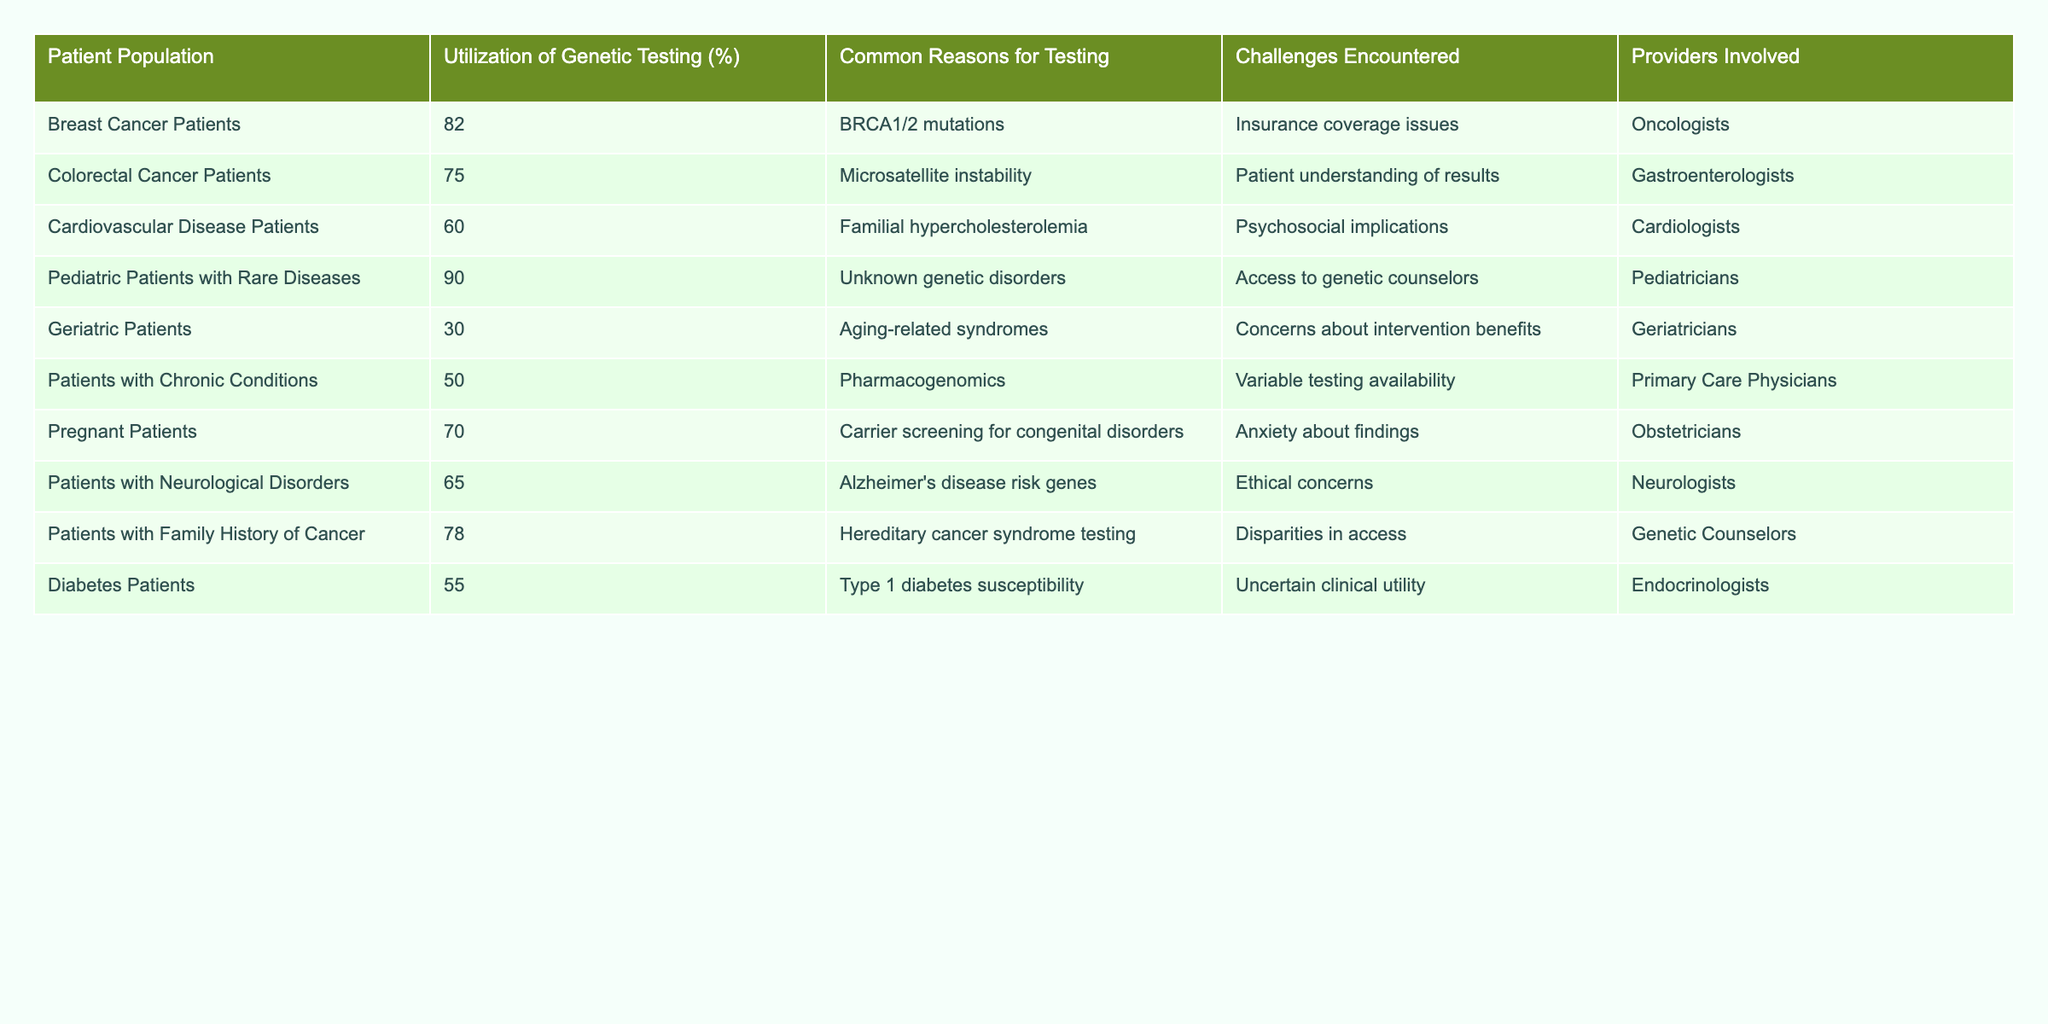What is the utilization rate of genetic testing for breast cancer patients? According to the table, the utilization of genetic testing for breast cancer patients is listed as 82%.
Answer: 82% Which patient population has the highest utilization of genetic testing? The data shows that pediatric patients with rare diseases have the highest utilization rate at 90%.
Answer: 90% What common reason for genetic testing is most frequently associated with geriatric patients? For geriatric patients, the common reason for testing is aging-related syndromes, as stated in the table.
Answer: Aging-related syndromes What percentage of patients with neurological disorders utilize genetic testing? The table indicates that 65% of patients with neurological disorders utilize genetic testing.
Answer: 65% How does the utilization of genetic testing for patients with chronic conditions compare to those with cardiovascular diseases? Patients with chronic conditions have a utilization rate of 50%, while those with cardiovascular diseases have a rate of 60%. The difference is 10%, showing that cardiovascular disease patients utilize genetic testing more.
Answer: 10% Is the utilization of genetic testing for patients with family history of cancer higher than for diabetic patients? Yes, the utilization for patients with a family history of cancer is 78%, which is higher than 55% for diabetic patients.
Answer: Yes What challenges are most commonly encountered by pediatric patients with rare diseases regarding genetic testing? The table states that the main challenge for pediatric patients with rare diseases is access to genetic counselors.
Answer: Access to genetic counselors What is the average utilization rate of genetic testing for patients across all populations provided in the table? To find the average, sum the utilization rates: 82 + 75 + 60 + 90 + 30 + 50 + 70 + 65 + 78 + 55 =  75. The average is 75/10 = 75.
Answer: 75 Which patient population experiences concerns about intervention benefits? The table indicates that geriatric patients experience concerns about intervention benefits as a challenge in genetic testing.
Answer: Geriatric patients What is the main challenge faced by colorectal cancer patients regarding genetic testing? The primary challenge for colorectal cancer patients is patient understanding of results, as indicated in the table.
Answer: Patient understanding of results Are patients with cardiovascular disease more likely to encounter psychosocial implications than pregnant patients? The table shows that cardiovascular disease patients face psychosocial implications, while pregnant patients face anxiety about findings. This means psychosocial implications are a challenge specifically mentioned for cardiovascular patients but not for pregnant patients.
Answer: Yes 